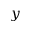<formula> <loc_0><loc_0><loc_500><loc_500>y</formula> 